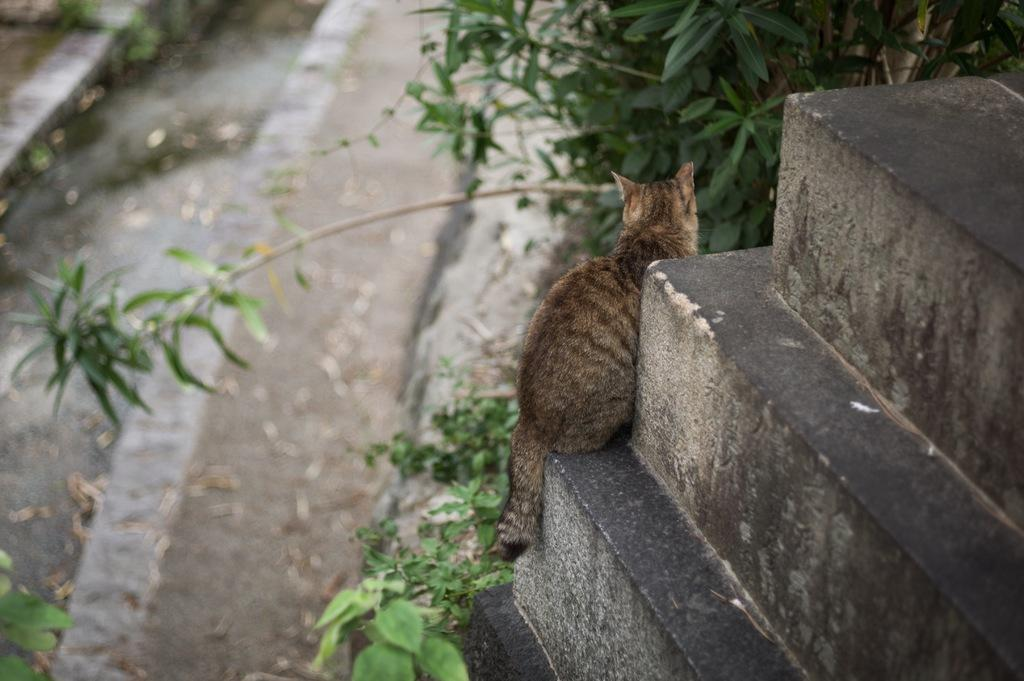What type of animal is in the image? There is a cat in the image. Where is the cat located in the image? The cat is sitting on the stairs. What else can be seen in the image besides the cat? There are plants in the image. What type of punishment is the cat receiving in the image? There is no indication in the image that the cat is receiving any punishment. 